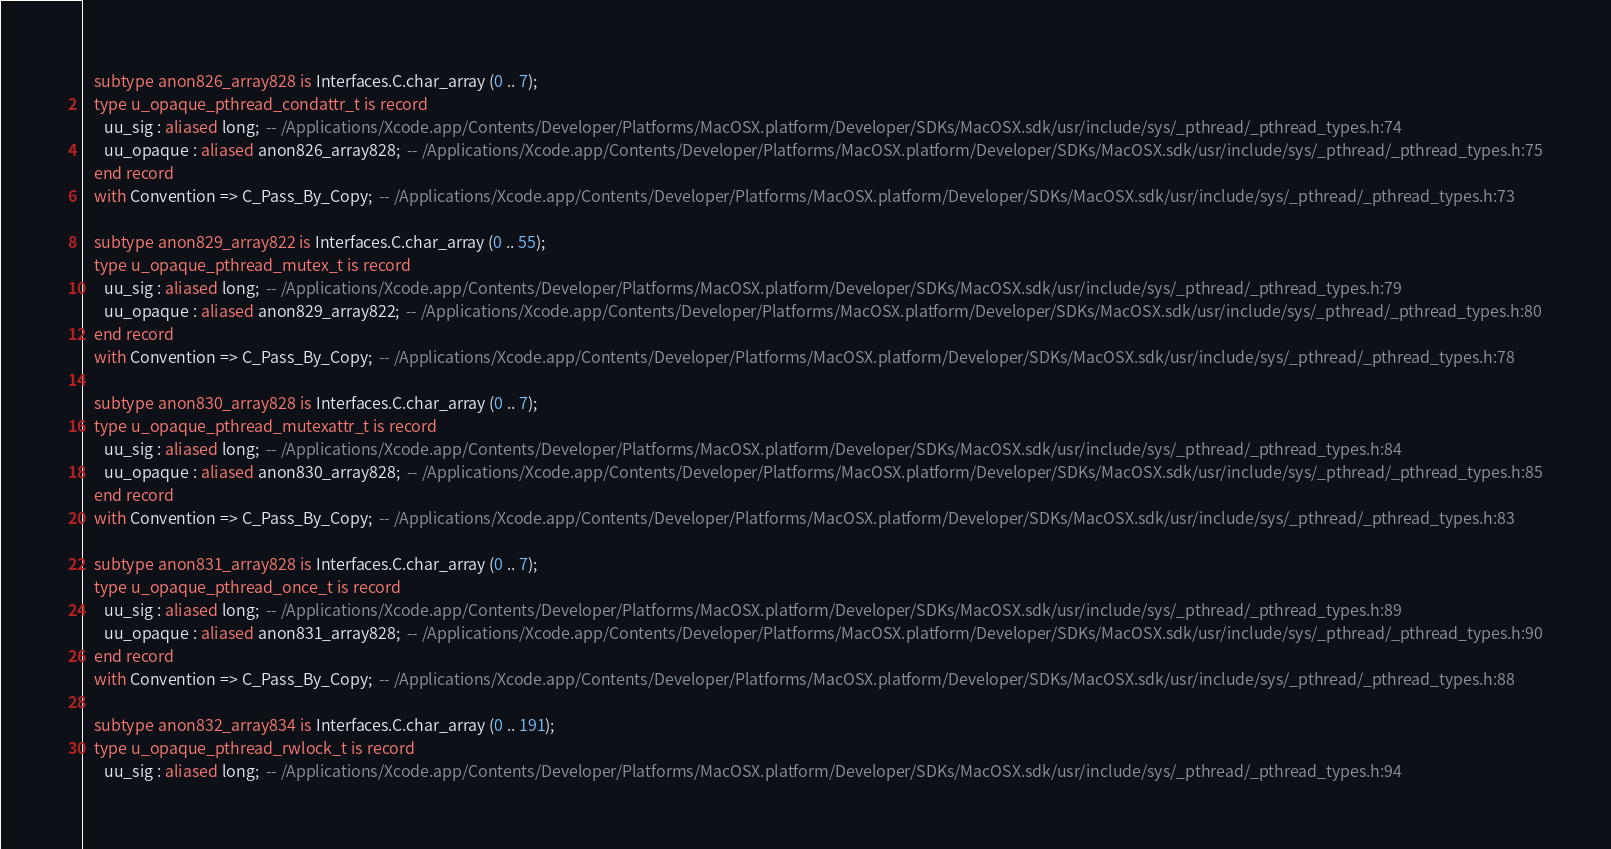<code> <loc_0><loc_0><loc_500><loc_500><_Ada_>   subtype anon826_array828 is Interfaces.C.char_array (0 .. 7);
   type u_opaque_pthread_condattr_t is record
      uu_sig : aliased long;  -- /Applications/Xcode.app/Contents/Developer/Platforms/MacOSX.platform/Developer/SDKs/MacOSX.sdk/usr/include/sys/_pthread/_pthread_types.h:74
      uu_opaque : aliased anon826_array828;  -- /Applications/Xcode.app/Contents/Developer/Platforms/MacOSX.platform/Developer/SDKs/MacOSX.sdk/usr/include/sys/_pthread/_pthread_types.h:75
   end record
   with Convention => C_Pass_By_Copy;  -- /Applications/Xcode.app/Contents/Developer/Platforms/MacOSX.platform/Developer/SDKs/MacOSX.sdk/usr/include/sys/_pthread/_pthread_types.h:73

   subtype anon829_array822 is Interfaces.C.char_array (0 .. 55);
   type u_opaque_pthread_mutex_t is record
      uu_sig : aliased long;  -- /Applications/Xcode.app/Contents/Developer/Platforms/MacOSX.platform/Developer/SDKs/MacOSX.sdk/usr/include/sys/_pthread/_pthread_types.h:79
      uu_opaque : aliased anon829_array822;  -- /Applications/Xcode.app/Contents/Developer/Platforms/MacOSX.platform/Developer/SDKs/MacOSX.sdk/usr/include/sys/_pthread/_pthread_types.h:80
   end record
   with Convention => C_Pass_By_Copy;  -- /Applications/Xcode.app/Contents/Developer/Platforms/MacOSX.platform/Developer/SDKs/MacOSX.sdk/usr/include/sys/_pthread/_pthread_types.h:78

   subtype anon830_array828 is Interfaces.C.char_array (0 .. 7);
   type u_opaque_pthread_mutexattr_t is record
      uu_sig : aliased long;  -- /Applications/Xcode.app/Contents/Developer/Platforms/MacOSX.platform/Developer/SDKs/MacOSX.sdk/usr/include/sys/_pthread/_pthread_types.h:84
      uu_opaque : aliased anon830_array828;  -- /Applications/Xcode.app/Contents/Developer/Platforms/MacOSX.platform/Developer/SDKs/MacOSX.sdk/usr/include/sys/_pthread/_pthread_types.h:85
   end record
   with Convention => C_Pass_By_Copy;  -- /Applications/Xcode.app/Contents/Developer/Platforms/MacOSX.platform/Developer/SDKs/MacOSX.sdk/usr/include/sys/_pthread/_pthread_types.h:83

   subtype anon831_array828 is Interfaces.C.char_array (0 .. 7);
   type u_opaque_pthread_once_t is record
      uu_sig : aliased long;  -- /Applications/Xcode.app/Contents/Developer/Platforms/MacOSX.platform/Developer/SDKs/MacOSX.sdk/usr/include/sys/_pthread/_pthread_types.h:89
      uu_opaque : aliased anon831_array828;  -- /Applications/Xcode.app/Contents/Developer/Platforms/MacOSX.platform/Developer/SDKs/MacOSX.sdk/usr/include/sys/_pthread/_pthread_types.h:90
   end record
   with Convention => C_Pass_By_Copy;  -- /Applications/Xcode.app/Contents/Developer/Platforms/MacOSX.platform/Developer/SDKs/MacOSX.sdk/usr/include/sys/_pthread/_pthread_types.h:88

   subtype anon832_array834 is Interfaces.C.char_array (0 .. 191);
   type u_opaque_pthread_rwlock_t is record
      uu_sig : aliased long;  -- /Applications/Xcode.app/Contents/Developer/Platforms/MacOSX.platform/Developer/SDKs/MacOSX.sdk/usr/include/sys/_pthread/_pthread_types.h:94</code> 